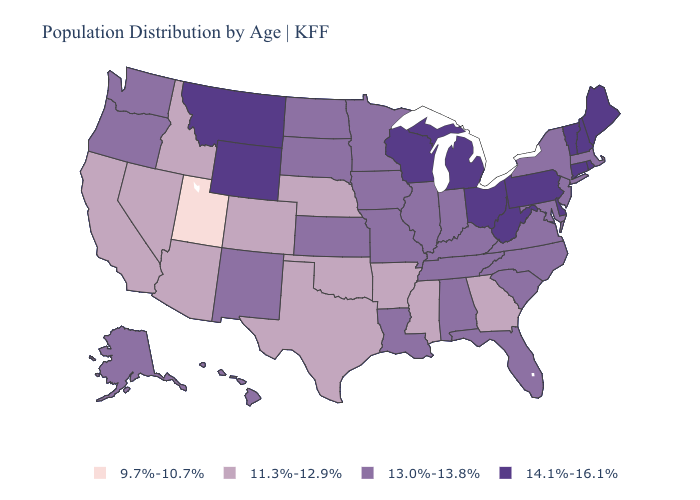Name the states that have a value in the range 13.0%-13.8%?
Short answer required. Alabama, Alaska, Florida, Hawaii, Illinois, Indiana, Iowa, Kansas, Kentucky, Louisiana, Maryland, Massachusetts, Minnesota, Missouri, New Jersey, New Mexico, New York, North Carolina, North Dakota, Oregon, South Carolina, South Dakota, Tennessee, Virginia, Washington. What is the lowest value in states that border New Jersey?
Keep it brief. 13.0%-13.8%. What is the lowest value in the USA?
Write a very short answer. 9.7%-10.7%. Which states have the highest value in the USA?
Concise answer only. Connecticut, Delaware, Maine, Michigan, Montana, New Hampshire, Ohio, Pennsylvania, Rhode Island, Vermont, West Virginia, Wisconsin, Wyoming. Name the states that have a value in the range 9.7%-10.7%?
Short answer required. Utah. What is the highest value in the West ?
Write a very short answer. 14.1%-16.1%. What is the highest value in states that border West Virginia?
Give a very brief answer. 14.1%-16.1%. What is the lowest value in the USA?
Keep it brief. 9.7%-10.7%. Does Louisiana have the highest value in the South?
Give a very brief answer. No. What is the value of Alaska?
Give a very brief answer. 13.0%-13.8%. Among the states that border Idaho , which have the lowest value?
Answer briefly. Utah. What is the value of Kentucky?
Quick response, please. 13.0%-13.8%. How many symbols are there in the legend?
Short answer required. 4. 